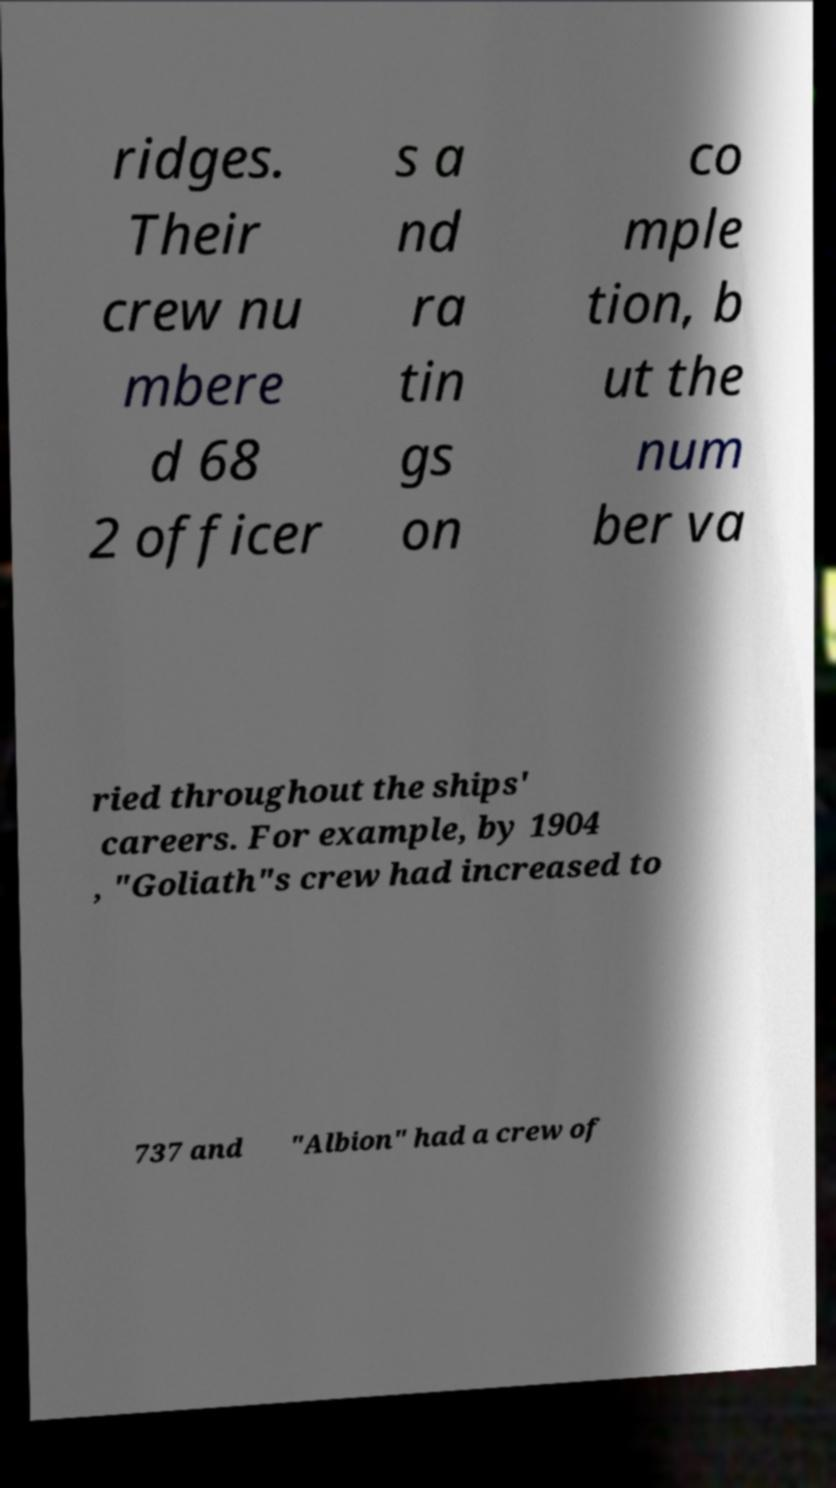I need the written content from this picture converted into text. Can you do that? ridges. Their crew nu mbere d 68 2 officer s a nd ra tin gs on co mple tion, b ut the num ber va ried throughout the ships' careers. For example, by 1904 , "Goliath"s crew had increased to 737 and "Albion" had a crew of 